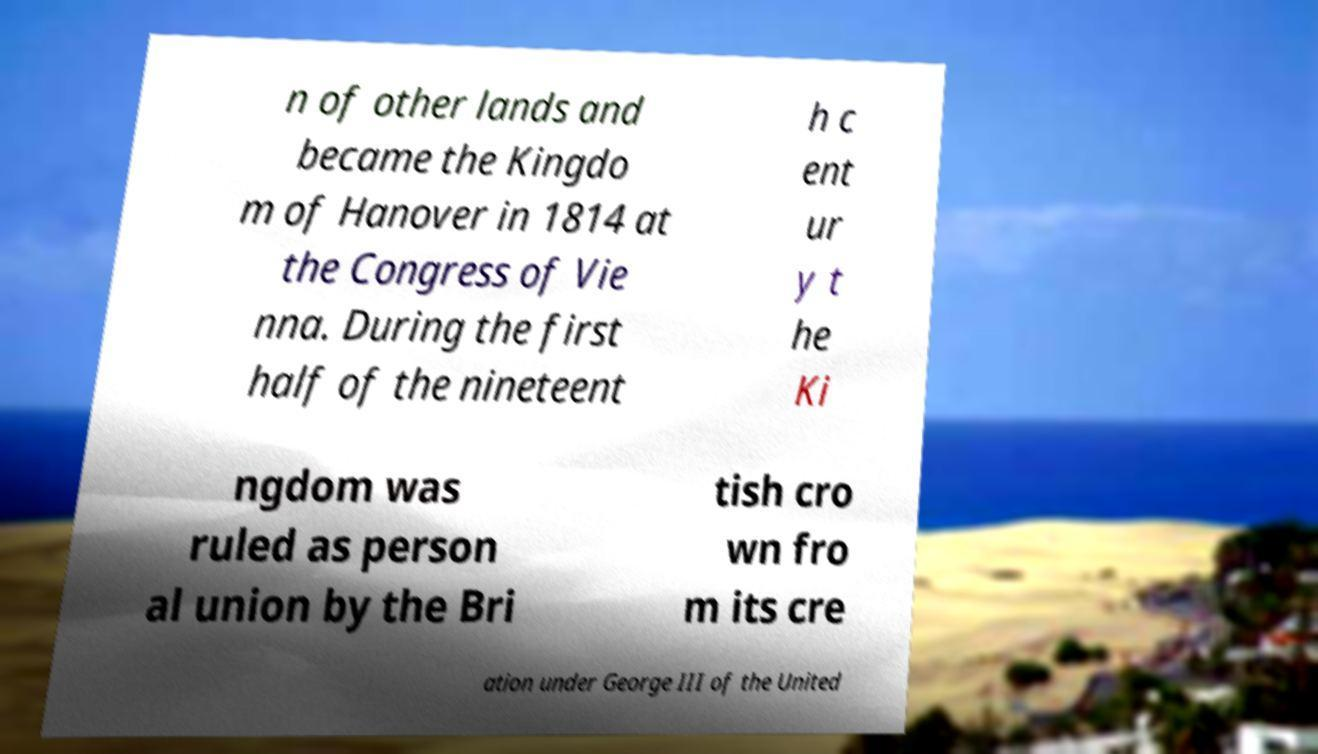Can you accurately transcribe the text from the provided image for me? n of other lands and became the Kingdo m of Hanover in 1814 at the Congress of Vie nna. During the first half of the nineteent h c ent ur y t he Ki ngdom was ruled as person al union by the Bri tish cro wn fro m its cre ation under George III of the United 